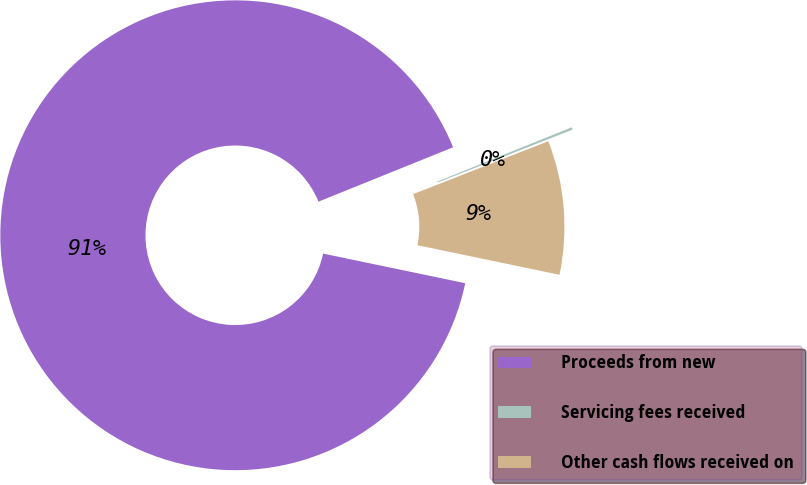Convert chart. <chart><loc_0><loc_0><loc_500><loc_500><pie_chart><fcel>Proceeds from new<fcel>Servicing fees received<fcel>Other cash flows received on<nl><fcel>90.62%<fcel>0.17%<fcel>9.21%<nl></chart> 